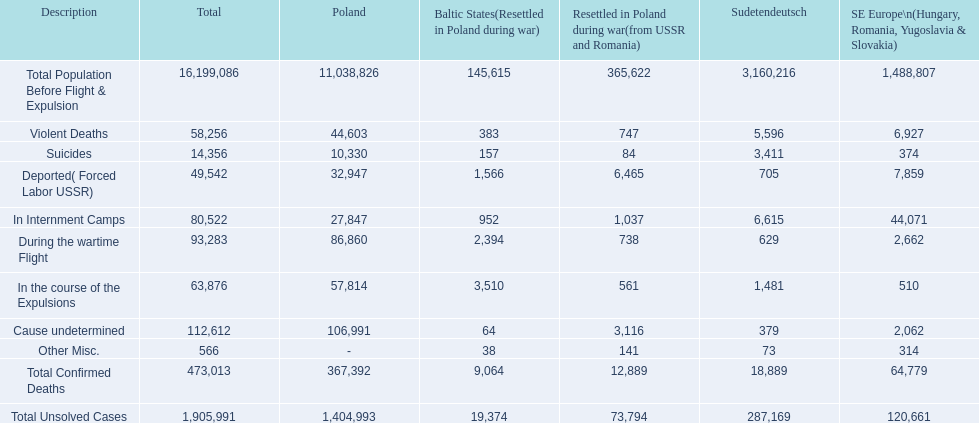What were all of the types of deaths? Violent Deaths, Suicides, Deported( Forced Labor USSR), In Internment Camps, During the wartime Flight, In the course of the Expulsions, Cause undetermined, Other Misc. And their totals in the baltic states? 383, 157, 1,566, 952, 2,394, 3,510, 64, 38. Were more deaths in the baltic states caused by undetermined causes or misc.? Cause undetermined. 